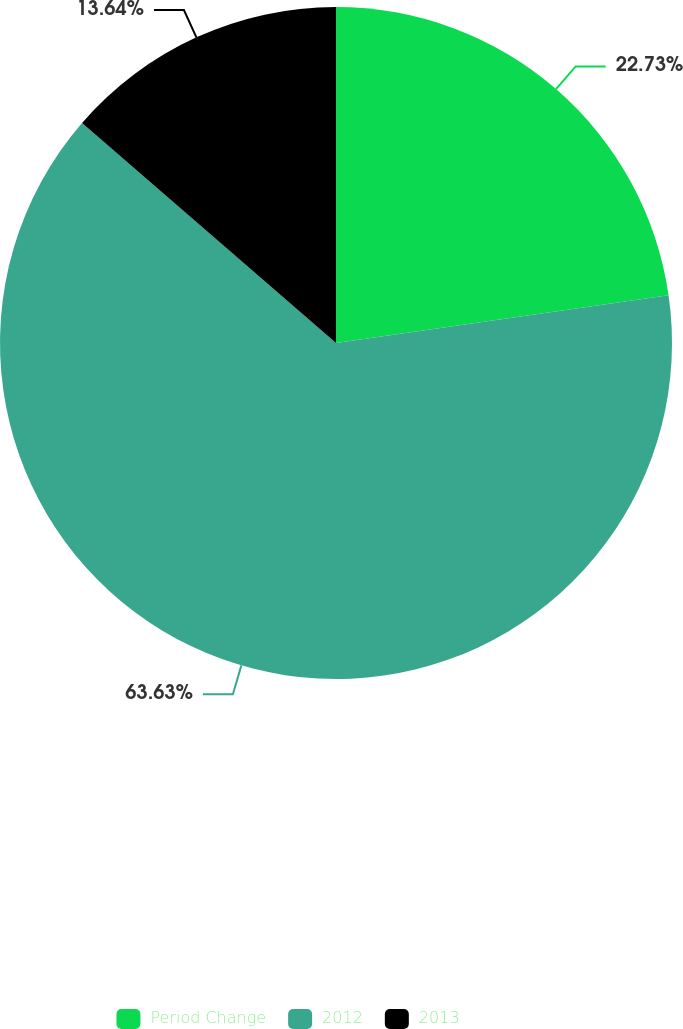Convert chart. <chart><loc_0><loc_0><loc_500><loc_500><pie_chart><fcel>Period Change<fcel>2012<fcel>2013<nl><fcel>22.73%<fcel>63.64%<fcel>13.64%<nl></chart> 